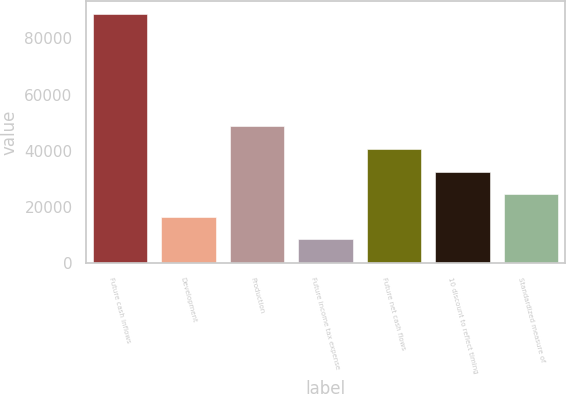Convert chart. <chart><loc_0><loc_0><loc_500><loc_500><bar_chart><fcel>Future cash inflows<fcel>Development<fcel>Production<fcel>Future income tax expense<fcel>Future net cash flows<fcel>10 discount to reflect timing<fcel>Standardized measure of<nl><fcel>88867<fcel>16567.3<fcel>48700.5<fcel>8534<fcel>40667.2<fcel>32633.9<fcel>24600.6<nl></chart> 